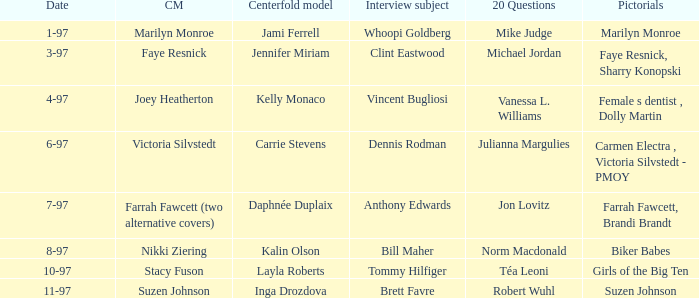When was Kalin Olson listed as  the centerfold model? 8-97. 